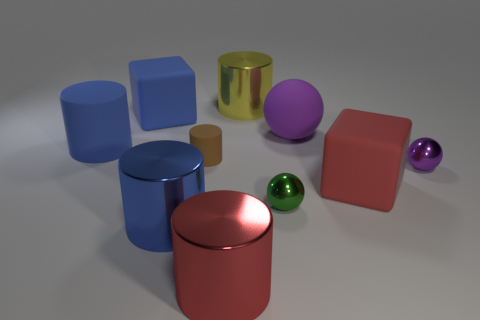Is the number of big blue cylinders in front of the blue metallic thing the same as the number of brown metal spheres?
Offer a very short reply. Yes. How many cylinders are either small yellow shiny objects or red things?
Offer a terse response. 1. What color is the other cylinder that is the same material as the small brown cylinder?
Offer a terse response. Blue. Is the big purple thing made of the same material as the tiny object right of the red rubber thing?
Your answer should be compact. No. How many things are either blocks or brown things?
Offer a very short reply. 3. What material is the other big cylinder that is the same color as the big matte cylinder?
Provide a short and direct response. Metal. Are there any large blue metallic things of the same shape as the purple shiny thing?
Your answer should be compact. No. What number of green spheres are behind the red cube?
Provide a short and direct response. 0. What is the material of the red thing right of the tiny shiny sphere that is to the left of the small purple shiny ball?
Give a very brief answer. Rubber. There is a blue block that is the same size as the matte sphere; what material is it?
Keep it short and to the point. Rubber. 